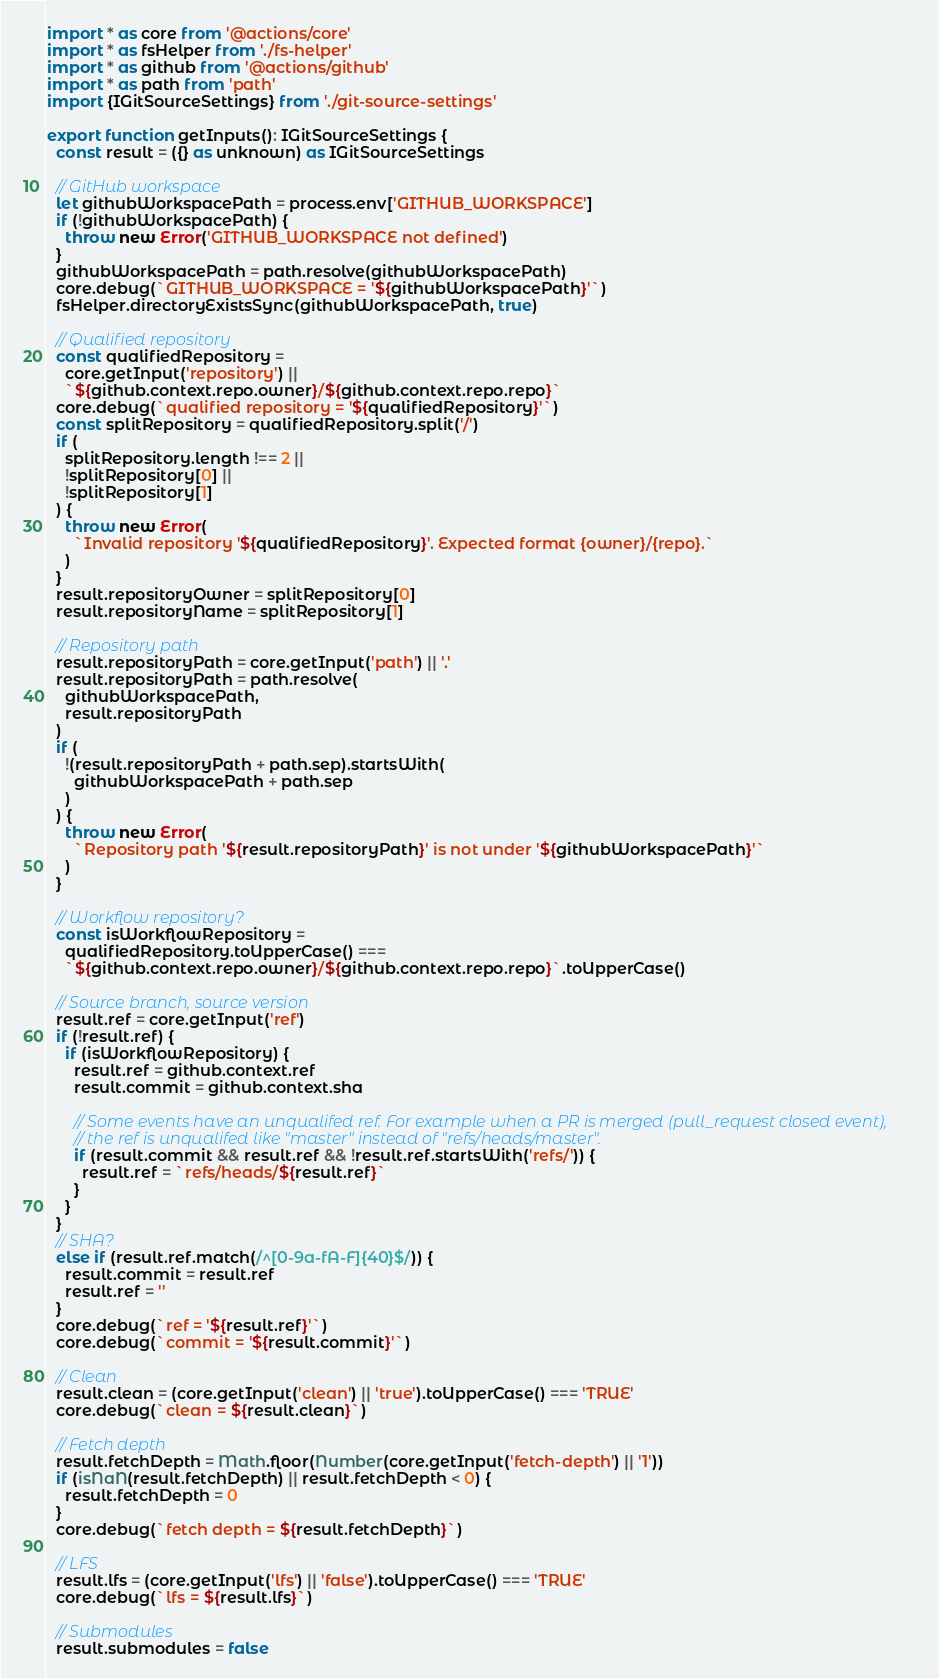Convert code to text. <code><loc_0><loc_0><loc_500><loc_500><_TypeScript_>import * as core from '@actions/core'
import * as fsHelper from './fs-helper'
import * as github from '@actions/github'
import * as path from 'path'
import {IGitSourceSettings} from './git-source-settings'

export function getInputs(): IGitSourceSettings {
  const result = ({} as unknown) as IGitSourceSettings

  // GitHub workspace
  let githubWorkspacePath = process.env['GITHUB_WORKSPACE']
  if (!githubWorkspacePath) {
    throw new Error('GITHUB_WORKSPACE not defined')
  }
  githubWorkspacePath = path.resolve(githubWorkspacePath)
  core.debug(`GITHUB_WORKSPACE = '${githubWorkspacePath}'`)
  fsHelper.directoryExistsSync(githubWorkspacePath, true)

  // Qualified repository
  const qualifiedRepository =
    core.getInput('repository') ||
    `${github.context.repo.owner}/${github.context.repo.repo}`
  core.debug(`qualified repository = '${qualifiedRepository}'`)
  const splitRepository = qualifiedRepository.split('/')
  if (
    splitRepository.length !== 2 ||
    !splitRepository[0] ||
    !splitRepository[1]
  ) {
    throw new Error(
      `Invalid repository '${qualifiedRepository}'. Expected format {owner}/{repo}.`
    )
  }
  result.repositoryOwner = splitRepository[0]
  result.repositoryName = splitRepository[1]

  // Repository path
  result.repositoryPath = core.getInput('path') || '.'
  result.repositoryPath = path.resolve(
    githubWorkspacePath,
    result.repositoryPath
  )
  if (
    !(result.repositoryPath + path.sep).startsWith(
      githubWorkspacePath + path.sep
    )
  ) {
    throw new Error(
      `Repository path '${result.repositoryPath}' is not under '${githubWorkspacePath}'`
    )
  }

  // Workflow repository?
  const isWorkflowRepository =
    qualifiedRepository.toUpperCase() ===
    `${github.context.repo.owner}/${github.context.repo.repo}`.toUpperCase()

  // Source branch, source version
  result.ref = core.getInput('ref')
  if (!result.ref) {
    if (isWorkflowRepository) {
      result.ref = github.context.ref
      result.commit = github.context.sha

      // Some events have an unqualifed ref. For example when a PR is merged (pull_request closed event),
      // the ref is unqualifed like "master" instead of "refs/heads/master".
      if (result.commit && result.ref && !result.ref.startsWith('refs/')) {
        result.ref = `refs/heads/${result.ref}`
      }
    }
  }
  // SHA?
  else if (result.ref.match(/^[0-9a-fA-F]{40}$/)) {
    result.commit = result.ref
    result.ref = ''
  }
  core.debug(`ref = '${result.ref}'`)
  core.debug(`commit = '${result.commit}'`)

  // Clean
  result.clean = (core.getInput('clean') || 'true').toUpperCase() === 'TRUE'
  core.debug(`clean = ${result.clean}`)

  // Fetch depth
  result.fetchDepth = Math.floor(Number(core.getInput('fetch-depth') || '1'))
  if (isNaN(result.fetchDepth) || result.fetchDepth < 0) {
    result.fetchDepth = 0
  }
  core.debug(`fetch depth = ${result.fetchDepth}`)

  // LFS
  result.lfs = (core.getInput('lfs') || 'false').toUpperCase() === 'TRUE'
  core.debug(`lfs = ${result.lfs}`)

  // Submodules
  result.submodules = false</code> 